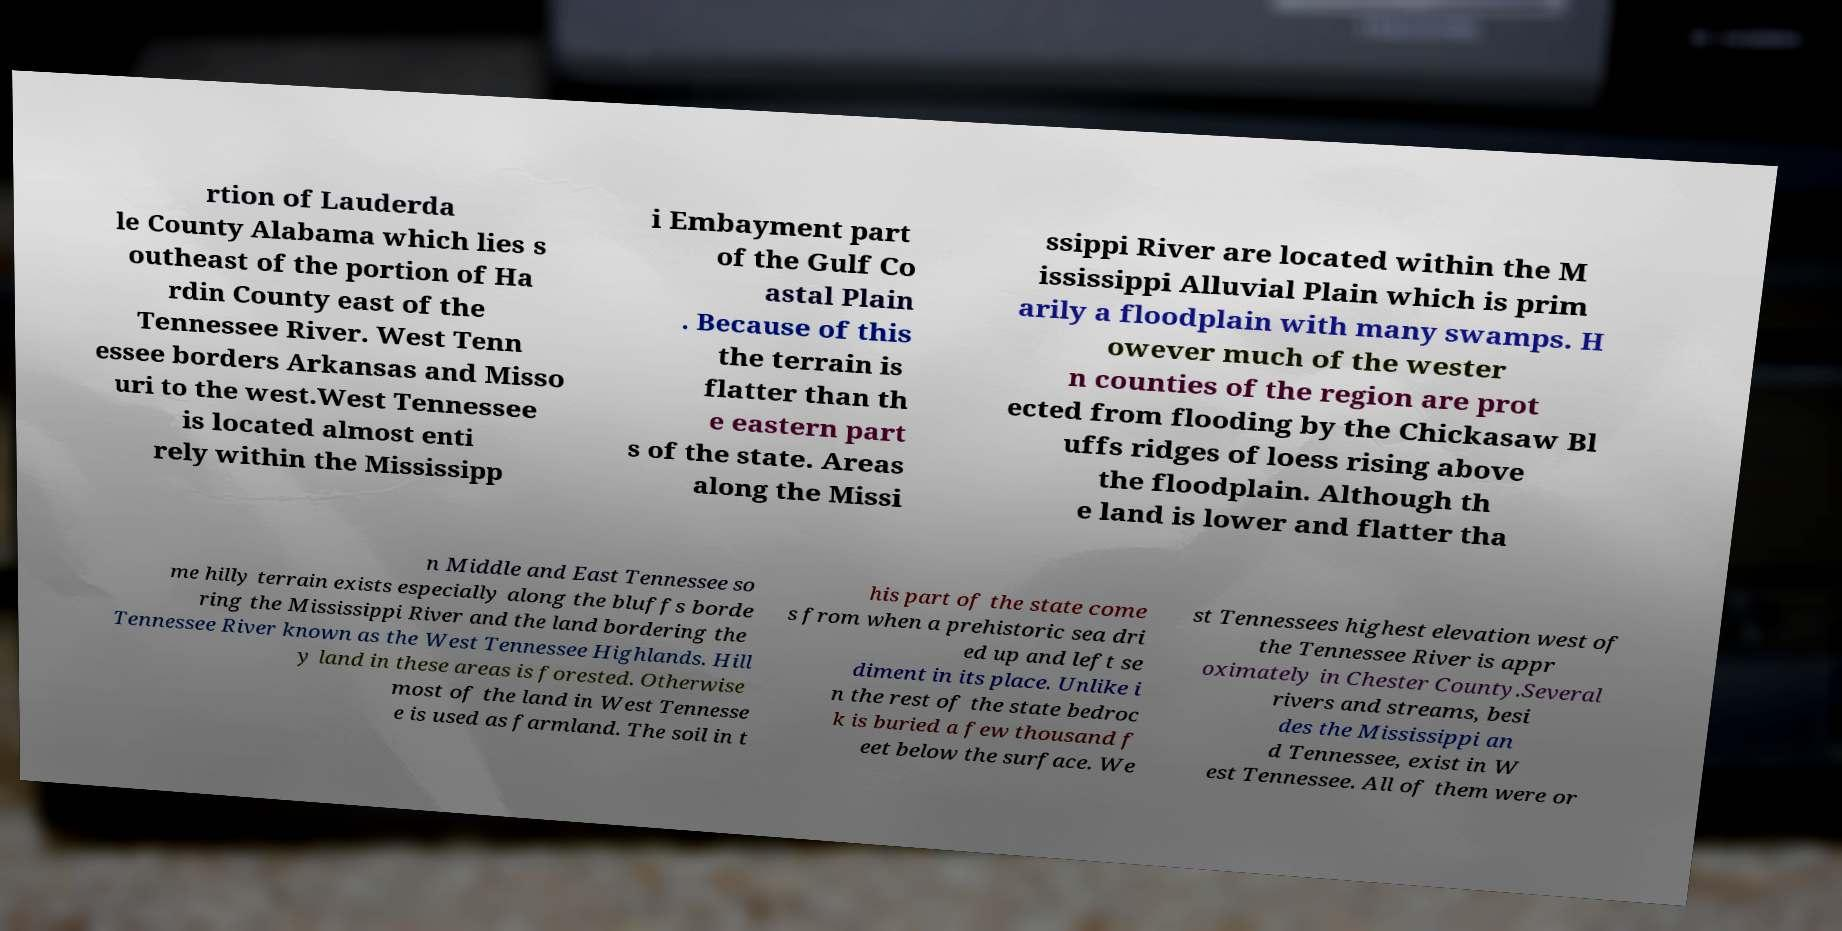What messages or text are displayed in this image? I need them in a readable, typed format. rtion of Lauderda le County Alabama which lies s outheast of the portion of Ha rdin County east of the Tennessee River. West Tenn essee borders Arkansas and Misso uri to the west.West Tennessee is located almost enti rely within the Mississipp i Embayment part of the Gulf Co astal Plain . Because of this the terrain is flatter than th e eastern part s of the state. Areas along the Missi ssippi River are located within the M ississippi Alluvial Plain which is prim arily a floodplain with many swamps. H owever much of the wester n counties of the region are prot ected from flooding by the Chickasaw Bl uffs ridges of loess rising above the floodplain. Although th e land is lower and flatter tha n Middle and East Tennessee so me hilly terrain exists especially along the bluffs borde ring the Mississippi River and the land bordering the Tennessee River known as the West Tennessee Highlands. Hill y land in these areas is forested. Otherwise most of the land in West Tennesse e is used as farmland. The soil in t his part of the state come s from when a prehistoric sea dri ed up and left se diment in its place. Unlike i n the rest of the state bedroc k is buried a few thousand f eet below the surface. We st Tennessees highest elevation west of the Tennessee River is appr oximately in Chester County.Several rivers and streams, besi des the Mississippi an d Tennessee, exist in W est Tennessee. All of them were or 